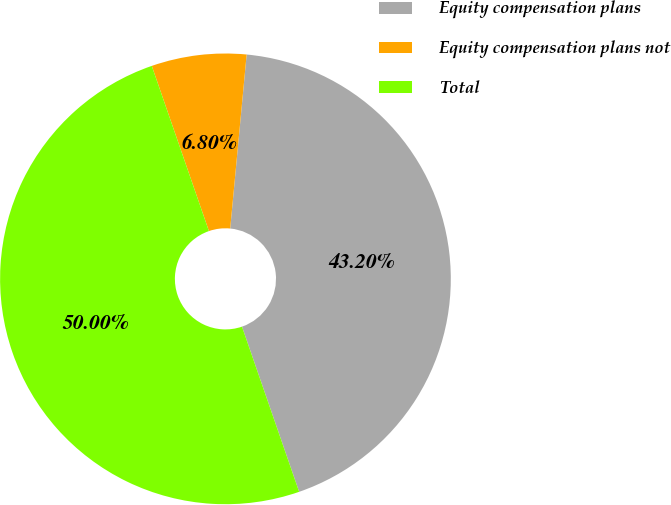Convert chart to OTSL. <chart><loc_0><loc_0><loc_500><loc_500><pie_chart><fcel>Equity compensation plans<fcel>Equity compensation plans not<fcel>Total<nl><fcel>43.2%<fcel>6.8%<fcel>50.0%<nl></chart> 